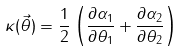<formula> <loc_0><loc_0><loc_500><loc_500>\kappa ( \vec { \theta } ) = \frac { 1 } { 2 } \left ( \frac { \partial \alpha _ { 1 } } { \partial \theta _ { 1 } } + \frac { \partial \alpha _ { 2 } } { \partial \theta _ { 2 } } \right )</formula> 